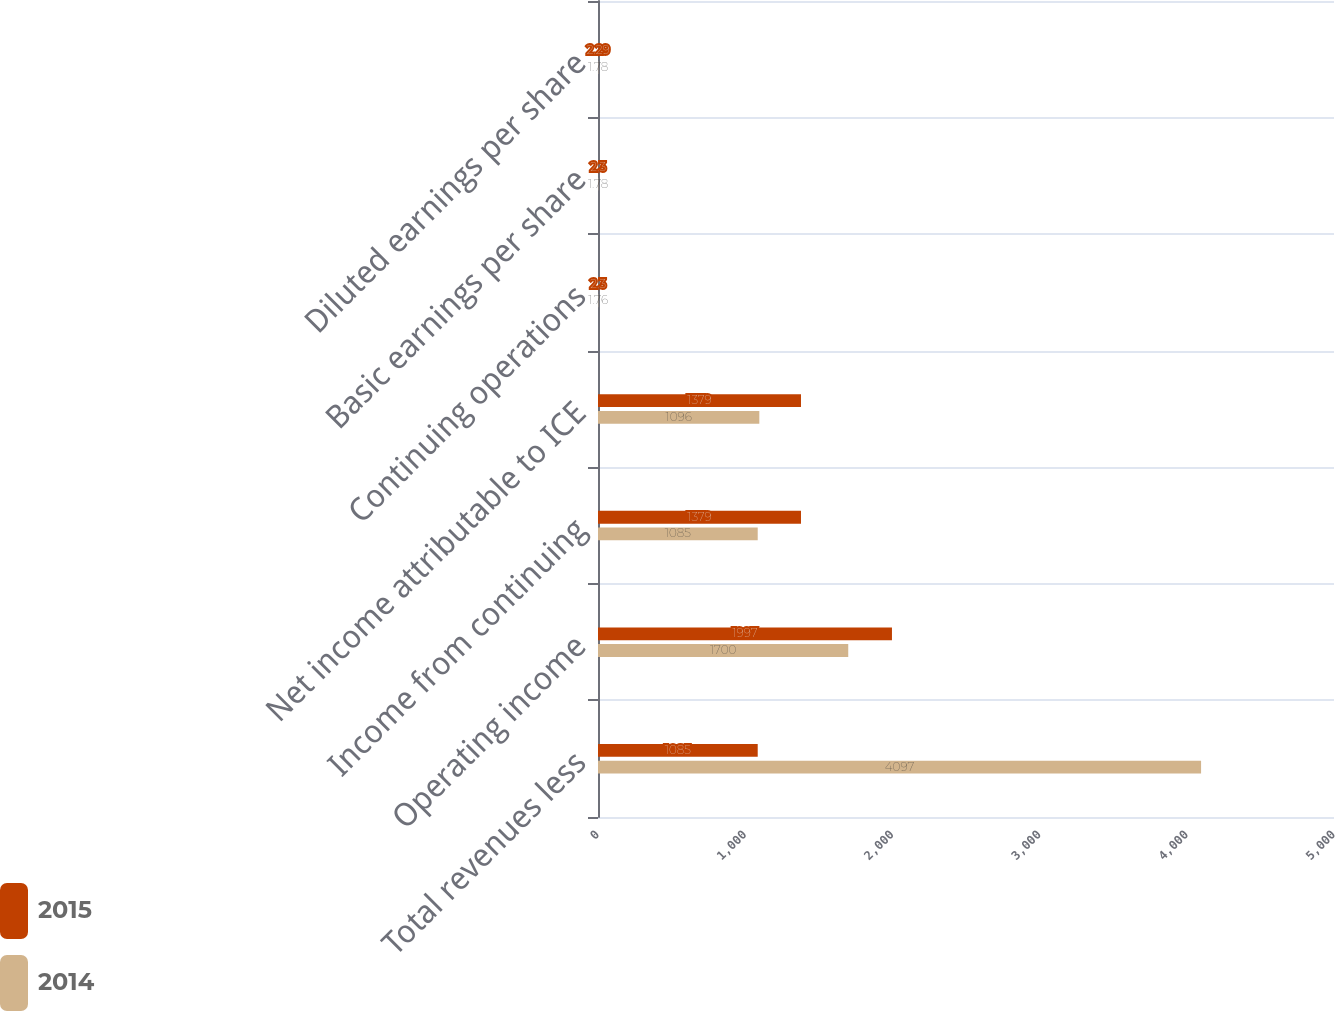<chart> <loc_0><loc_0><loc_500><loc_500><stacked_bar_chart><ecel><fcel>Total revenues less<fcel>Operating income<fcel>Income from continuing<fcel>Net income attributable to ICE<fcel>Continuing operations<fcel>Basic earnings per share<fcel>Diluted earnings per share<nl><fcel>2015<fcel>1085<fcel>1997<fcel>1379<fcel>1379<fcel>2.3<fcel>2.3<fcel>2.29<nl><fcel>2014<fcel>4097<fcel>1700<fcel>1085<fcel>1096<fcel>1.76<fcel>1.78<fcel>1.78<nl></chart> 